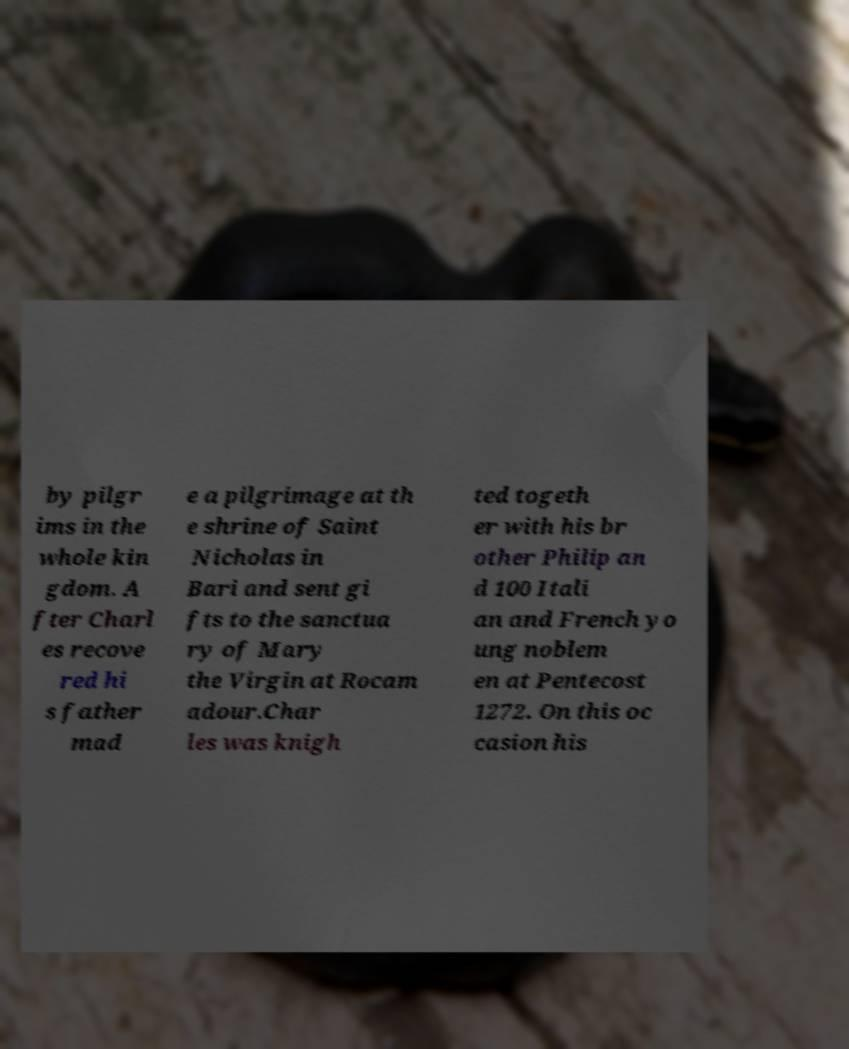Can you accurately transcribe the text from the provided image for me? by pilgr ims in the whole kin gdom. A fter Charl es recove red hi s father mad e a pilgrimage at th e shrine of Saint Nicholas in Bari and sent gi fts to the sanctua ry of Mary the Virgin at Rocam adour.Char les was knigh ted togeth er with his br other Philip an d 100 Itali an and French yo ung noblem en at Pentecost 1272. On this oc casion his 